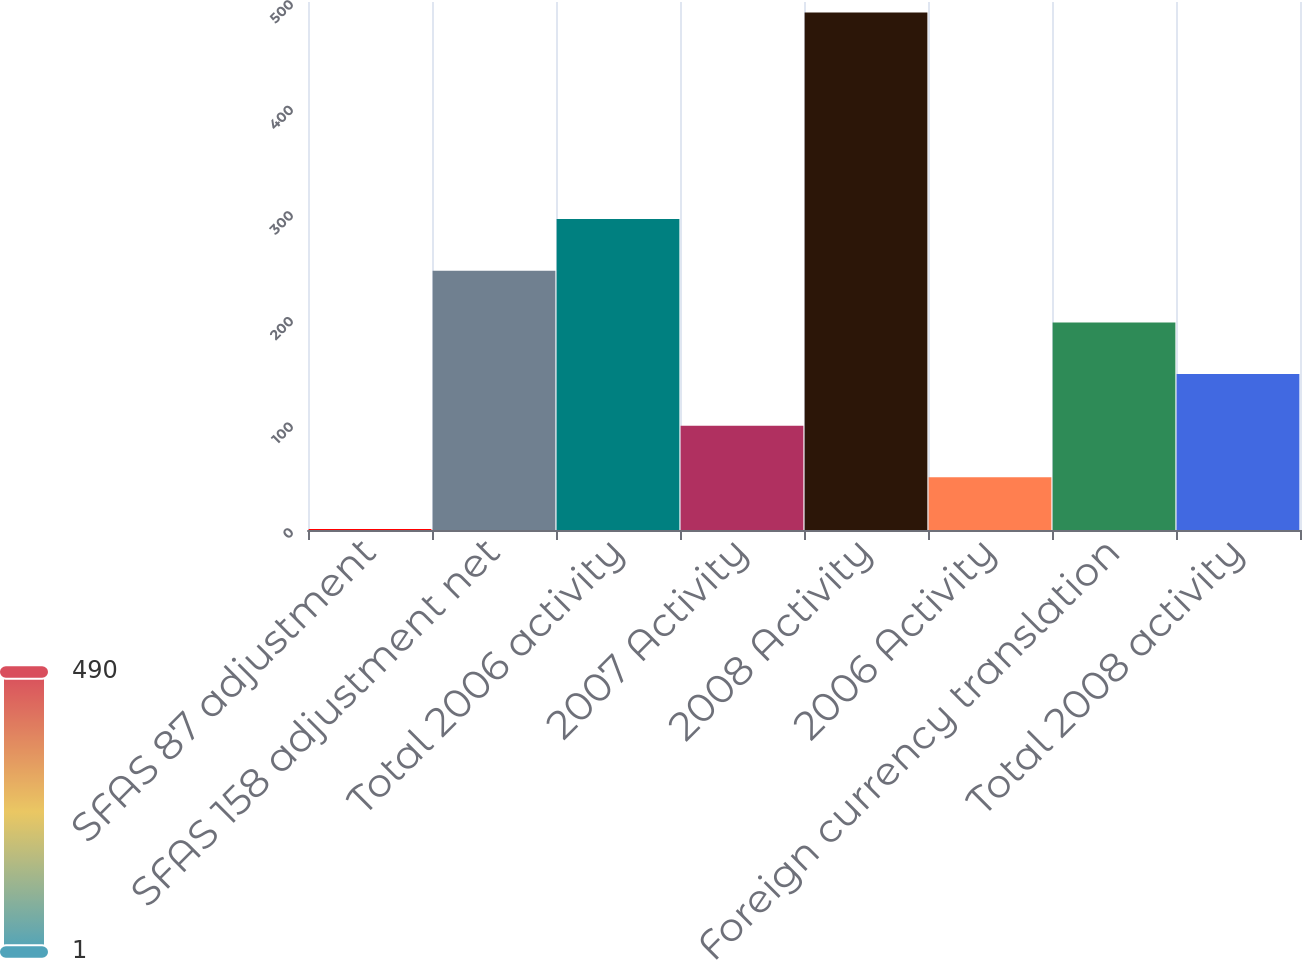Convert chart. <chart><loc_0><loc_0><loc_500><loc_500><bar_chart><fcel>SFAS 87 adjustment<fcel>SFAS 158 adjustment net<fcel>Total 2006 activity<fcel>2007 Activity<fcel>2008 Activity<fcel>2006 Activity<fcel>Foreign currency translation<fcel>Total 2008 activity<nl><fcel>1<fcel>245.5<fcel>294.4<fcel>98.8<fcel>490<fcel>49.9<fcel>196.6<fcel>147.7<nl></chart> 